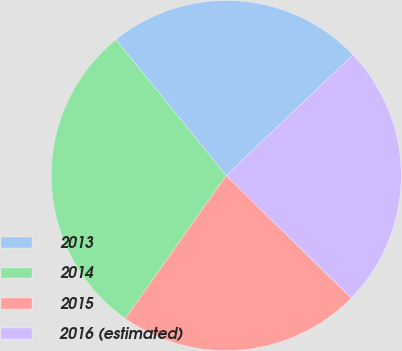Convert chart to OTSL. <chart><loc_0><loc_0><loc_500><loc_500><pie_chart><fcel>2013<fcel>2014<fcel>2015<fcel>2016 (estimated)<nl><fcel>23.75%<fcel>29.37%<fcel>22.45%<fcel>24.44%<nl></chart> 